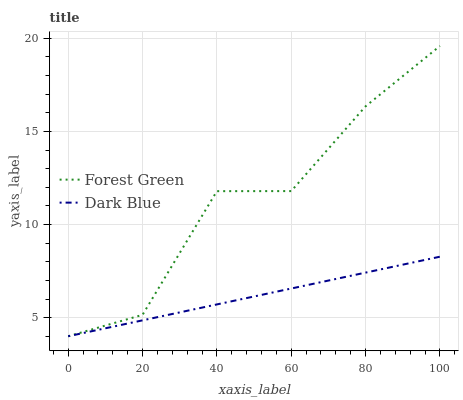Does Dark Blue have the minimum area under the curve?
Answer yes or no. Yes. Does Forest Green have the maximum area under the curve?
Answer yes or no. Yes. Does Forest Green have the minimum area under the curve?
Answer yes or no. No. Is Dark Blue the smoothest?
Answer yes or no. Yes. Is Forest Green the roughest?
Answer yes or no. Yes. Is Forest Green the smoothest?
Answer yes or no. No. Does Dark Blue have the lowest value?
Answer yes or no. Yes. Does Forest Green have the highest value?
Answer yes or no. Yes. Does Dark Blue intersect Forest Green?
Answer yes or no. Yes. Is Dark Blue less than Forest Green?
Answer yes or no. No. Is Dark Blue greater than Forest Green?
Answer yes or no. No. 